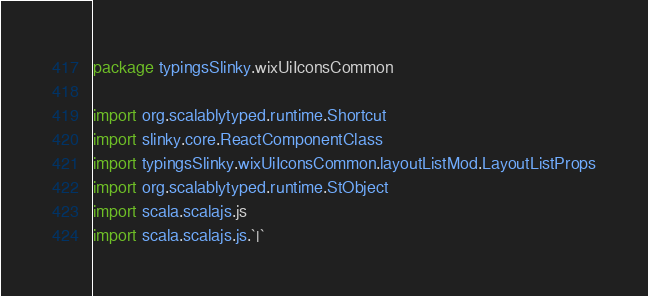Convert code to text. <code><loc_0><loc_0><loc_500><loc_500><_Scala_>package typingsSlinky.wixUiIconsCommon

import org.scalablytyped.runtime.Shortcut
import slinky.core.ReactComponentClass
import typingsSlinky.wixUiIconsCommon.layoutListMod.LayoutListProps
import org.scalablytyped.runtime.StObject
import scala.scalajs.js
import scala.scalajs.js.`|`</code> 